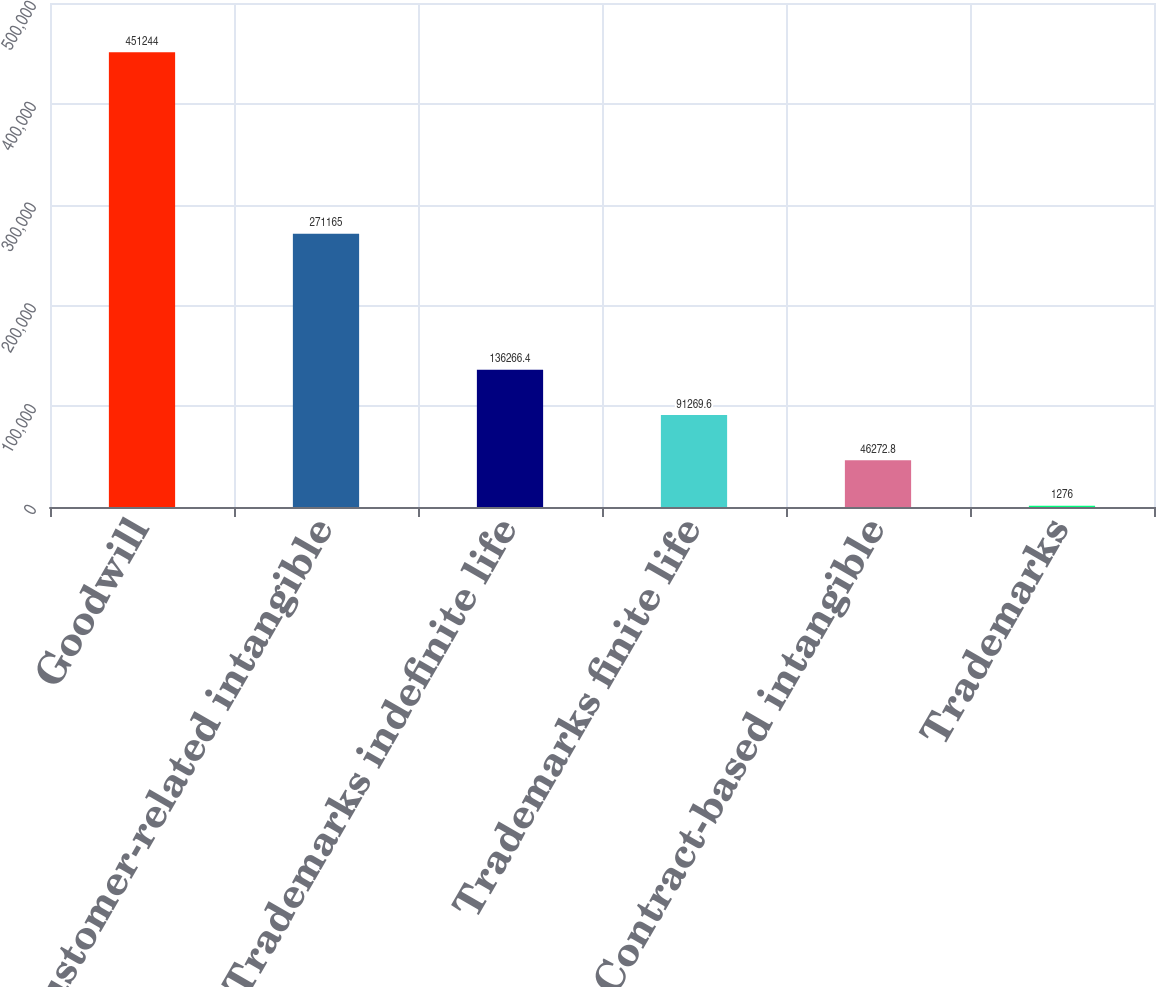Convert chart. <chart><loc_0><loc_0><loc_500><loc_500><bar_chart><fcel>Goodwill<fcel>Customer-related intangible<fcel>Trademarks indefinite life<fcel>Trademarks finite life<fcel>Contract-based intangible<fcel>Trademarks<nl><fcel>451244<fcel>271165<fcel>136266<fcel>91269.6<fcel>46272.8<fcel>1276<nl></chart> 